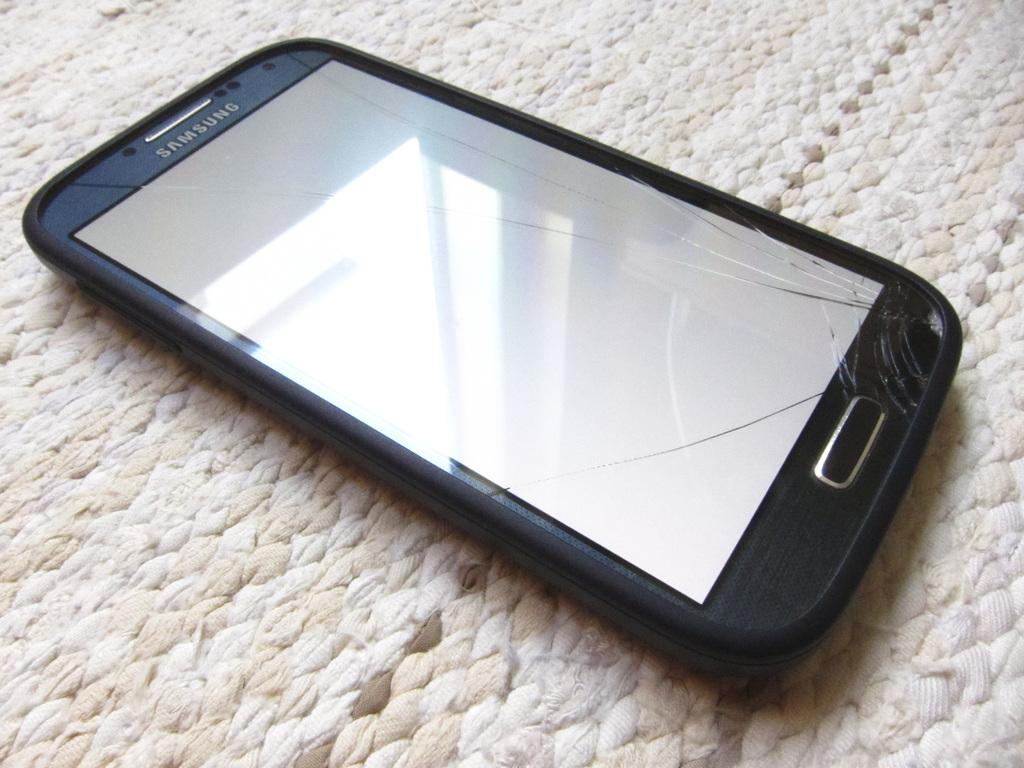What electronic device is in the image? There is a cell phone in the image. Where is the cell phone located in the image? The cell phone is in the center of the image. What type of rod can be seen in the image? There is no rod present in the image. Is there a fire visible in the image? No, there is no fire visible in the image. 